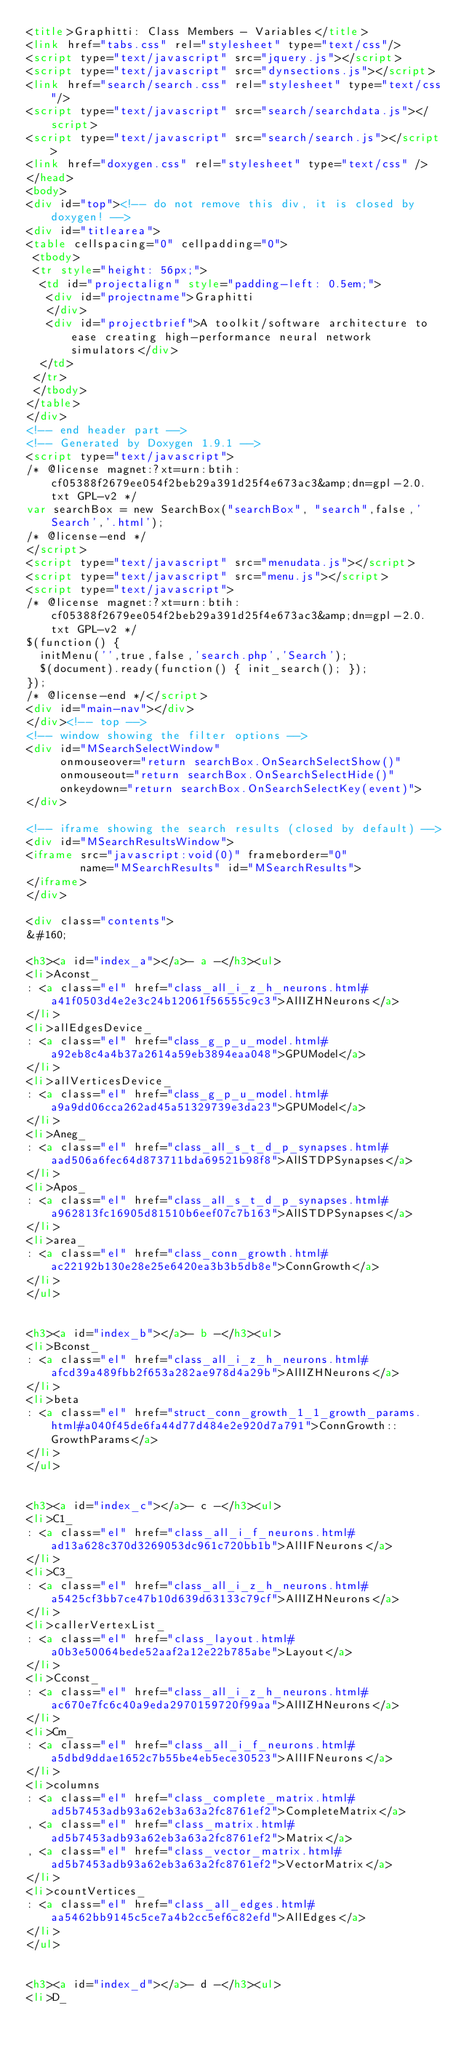Convert code to text. <code><loc_0><loc_0><loc_500><loc_500><_HTML_><title>Graphitti: Class Members - Variables</title>
<link href="tabs.css" rel="stylesheet" type="text/css"/>
<script type="text/javascript" src="jquery.js"></script>
<script type="text/javascript" src="dynsections.js"></script>
<link href="search/search.css" rel="stylesheet" type="text/css"/>
<script type="text/javascript" src="search/searchdata.js"></script>
<script type="text/javascript" src="search/search.js"></script>
<link href="doxygen.css" rel="stylesheet" type="text/css" />
</head>
<body>
<div id="top"><!-- do not remove this div, it is closed by doxygen! -->
<div id="titlearea">
<table cellspacing="0" cellpadding="0">
 <tbody>
 <tr style="height: 56px;">
  <td id="projectalign" style="padding-left: 0.5em;">
   <div id="projectname">Graphitti
   </div>
   <div id="projectbrief">A toolkit/software architecture to ease creating high-performance neural network simulators</div>
  </td>
 </tr>
 </tbody>
</table>
</div>
<!-- end header part -->
<!-- Generated by Doxygen 1.9.1 -->
<script type="text/javascript">
/* @license magnet:?xt=urn:btih:cf05388f2679ee054f2beb29a391d25f4e673ac3&amp;dn=gpl-2.0.txt GPL-v2 */
var searchBox = new SearchBox("searchBox", "search",false,'Search','.html');
/* @license-end */
</script>
<script type="text/javascript" src="menudata.js"></script>
<script type="text/javascript" src="menu.js"></script>
<script type="text/javascript">
/* @license magnet:?xt=urn:btih:cf05388f2679ee054f2beb29a391d25f4e673ac3&amp;dn=gpl-2.0.txt GPL-v2 */
$(function() {
  initMenu('',true,false,'search.php','Search');
  $(document).ready(function() { init_search(); });
});
/* @license-end */</script>
<div id="main-nav"></div>
</div><!-- top -->
<!-- window showing the filter options -->
<div id="MSearchSelectWindow"
     onmouseover="return searchBox.OnSearchSelectShow()"
     onmouseout="return searchBox.OnSearchSelectHide()"
     onkeydown="return searchBox.OnSearchSelectKey(event)">
</div>

<!-- iframe showing the search results (closed by default) -->
<div id="MSearchResultsWindow">
<iframe src="javascript:void(0)" frameborder="0" 
        name="MSearchResults" id="MSearchResults">
</iframe>
</div>

<div class="contents">
&#160;

<h3><a id="index_a"></a>- a -</h3><ul>
<li>Aconst_
: <a class="el" href="class_all_i_z_h_neurons.html#a41f0503d4e2e3c24b12061f56555c9c3">AllIZHNeurons</a>
</li>
<li>allEdgesDevice_
: <a class="el" href="class_g_p_u_model.html#a92eb8c4a4b37a2614a59eb3894eaa048">GPUModel</a>
</li>
<li>allVerticesDevice_
: <a class="el" href="class_g_p_u_model.html#a9a9dd06cca262ad45a51329739e3da23">GPUModel</a>
</li>
<li>Aneg_
: <a class="el" href="class_all_s_t_d_p_synapses.html#aad506a6fec64d873711bda69521b98f8">AllSTDPSynapses</a>
</li>
<li>Apos_
: <a class="el" href="class_all_s_t_d_p_synapses.html#a962813fc16905d81510b6eef07c7b163">AllSTDPSynapses</a>
</li>
<li>area_
: <a class="el" href="class_conn_growth.html#ac22192b130e28e25e6420ea3b3b5db8e">ConnGrowth</a>
</li>
</ul>


<h3><a id="index_b"></a>- b -</h3><ul>
<li>Bconst_
: <a class="el" href="class_all_i_z_h_neurons.html#afcd39a489fbb2f653a282ae978d4a29b">AllIZHNeurons</a>
</li>
<li>beta
: <a class="el" href="struct_conn_growth_1_1_growth_params.html#a040f45de6fa44d77d484e2e920d7a791">ConnGrowth::GrowthParams</a>
</li>
</ul>


<h3><a id="index_c"></a>- c -</h3><ul>
<li>C1_
: <a class="el" href="class_all_i_f_neurons.html#ad13a628c370d3269053dc961c720bb1b">AllIFNeurons</a>
</li>
<li>C3_
: <a class="el" href="class_all_i_z_h_neurons.html#a5425cf3bb7ce47b10d639d63133c79cf">AllIZHNeurons</a>
</li>
<li>callerVertexList_
: <a class="el" href="class_layout.html#a0b3e50064bede52aaf2a12e22b785abe">Layout</a>
</li>
<li>Cconst_
: <a class="el" href="class_all_i_z_h_neurons.html#ac670e7fc6c40a9eda2970159720f99aa">AllIZHNeurons</a>
</li>
<li>Cm_
: <a class="el" href="class_all_i_f_neurons.html#a5dbd9ddae1652c7b55be4eb5ece30523">AllIFNeurons</a>
</li>
<li>columns
: <a class="el" href="class_complete_matrix.html#ad5b7453adb93a62eb3a63a2fc8761ef2">CompleteMatrix</a>
, <a class="el" href="class_matrix.html#ad5b7453adb93a62eb3a63a2fc8761ef2">Matrix</a>
, <a class="el" href="class_vector_matrix.html#ad5b7453adb93a62eb3a63a2fc8761ef2">VectorMatrix</a>
</li>
<li>countVertices_
: <a class="el" href="class_all_edges.html#aa5462bb9145c5ce7a4b2cc5ef6c82efd">AllEdges</a>
</li>
</ul>


<h3><a id="index_d"></a>- d -</h3><ul>
<li>D_</code> 